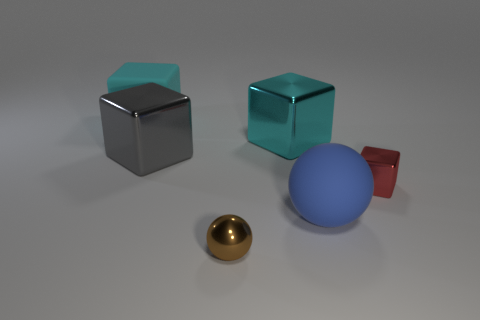Are there the same number of small shiny cubes that are on the left side of the brown sphere and big rubber blocks that are behind the cyan rubber cube?
Your answer should be very brief. Yes. Do the sphere that is to the left of the large blue ball and the object that is right of the matte sphere have the same size?
Offer a very short reply. Yes. There is a cube that is left of the big cyan shiny cube and in front of the large matte block; what material is it?
Your response must be concise. Metal. Are there fewer tiny blocks than blocks?
Provide a succinct answer. Yes. There is a shiny cube that is left of the metallic object in front of the small metallic cube; how big is it?
Give a very brief answer. Large. What shape is the thing that is on the right side of the blue rubber ball that is to the right of the big block to the right of the brown ball?
Your answer should be compact. Cube. There is a large object that is the same material as the blue sphere; what is its color?
Keep it short and to the point. Cyan. There is a cube that is on the left side of the metal object on the left side of the small metal thing left of the tiny red object; what is its color?
Ensure brevity in your answer.  Cyan. What number of spheres are either red rubber objects or cyan objects?
Your response must be concise. 0. There is another big block that is the same color as the matte cube; what material is it?
Your answer should be compact. Metal. 